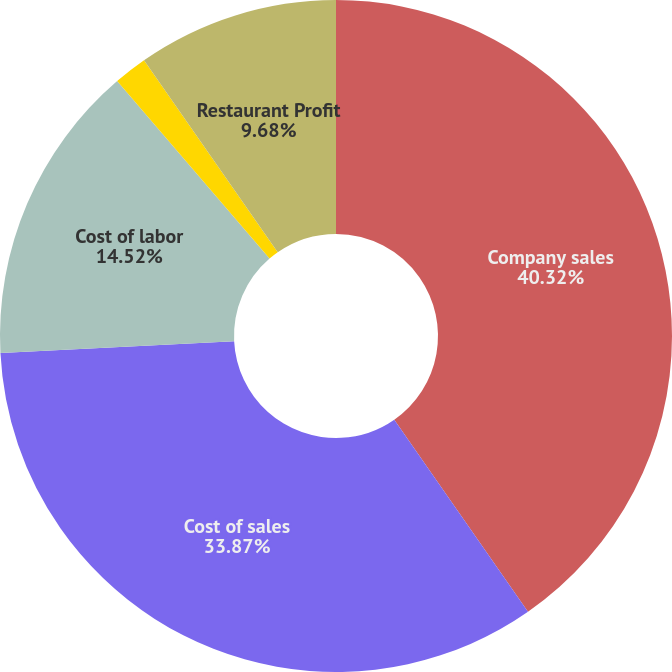Convert chart to OTSL. <chart><loc_0><loc_0><loc_500><loc_500><pie_chart><fcel>Company sales<fcel>Cost of sales<fcel>Cost of labor<fcel>Occupancy and other<fcel>Restaurant Profit<nl><fcel>40.32%<fcel>33.87%<fcel>14.52%<fcel>1.61%<fcel>9.68%<nl></chart> 